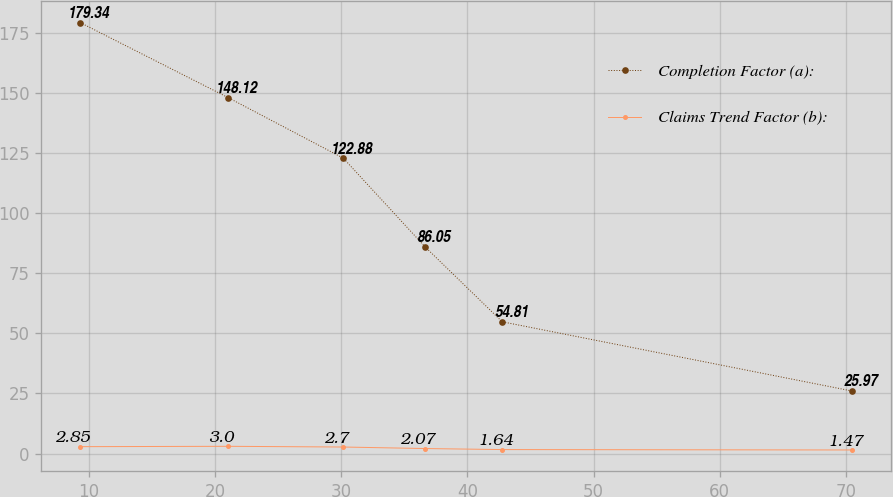Convert chart to OTSL. <chart><loc_0><loc_0><loc_500><loc_500><line_chart><ecel><fcel>Completion Factor (a):<fcel>Claims Trend Factor (b):<nl><fcel>9.28<fcel>179.34<fcel>2.85<nl><fcel>21.01<fcel>148.12<fcel>3<nl><fcel>30.16<fcel>122.88<fcel>2.7<nl><fcel>36.63<fcel>86.05<fcel>2.07<nl><fcel>42.76<fcel>54.81<fcel>1.64<nl><fcel>70.54<fcel>25.97<fcel>1.47<nl></chart> 